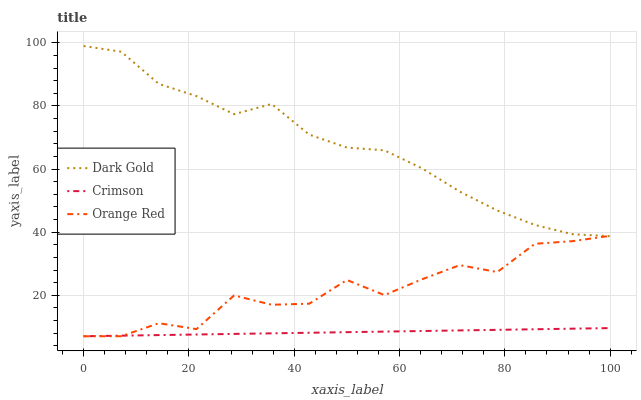Does Crimson have the minimum area under the curve?
Answer yes or no. Yes. Does Dark Gold have the maximum area under the curve?
Answer yes or no. Yes. Does Orange Red have the minimum area under the curve?
Answer yes or no. No. Does Orange Red have the maximum area under the curve?
Answer yes or no. No. Is Crimson the smoothest?
Answer yes or no. Yes. Is Orange Red the roughest?
Answer yes or no. Yes. Is Dark Gold the smoothest?
Answer yes or no. No. Is Dark Gold the roughest?
Answer yes or no. No. Does Dark Gold have the lowest value?
Answer yes or no. No. Does Dark Gold have the highest value?
Answer yes or no. Yes. Does Orange Red have the highest value?
Answer yes or no. No. Is Crimson less than Dark Gold?
Answer yes or no. Yes. Is Dark Gold greater than Crimson?
Answer yes or no. Yes. Does Dark Gold intersect Orange Red?
Answer yes or no. Yes. Is Dark Gold less than Orange Red?
Answer yes or no. No. Is Dark Gold greater than Orange Red?
Answer yes or no. No. Does Crimson intersect Dark Gold?
Answer yes or no. No. 